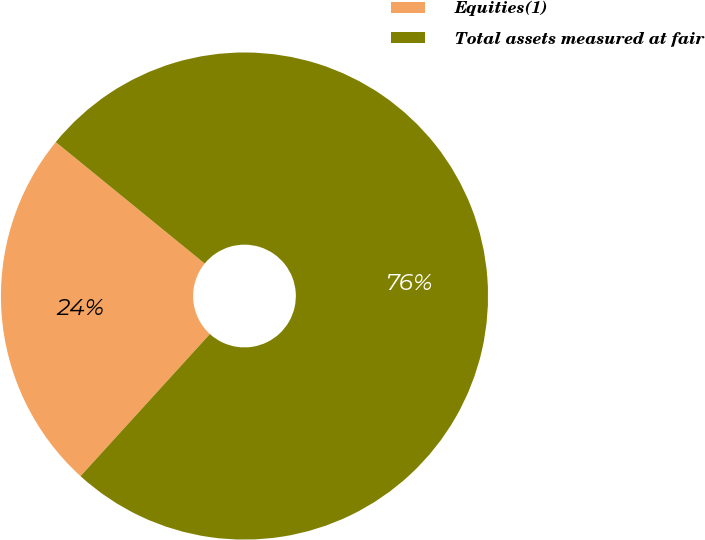<chart> <loc_0><loc_0><loc_500><loc_500><pie_chart><fcel>Equities(1)<fcel>Total assets measured at fair<nl><fcel>24.14%<fcel>75.86%<nl></chart> 